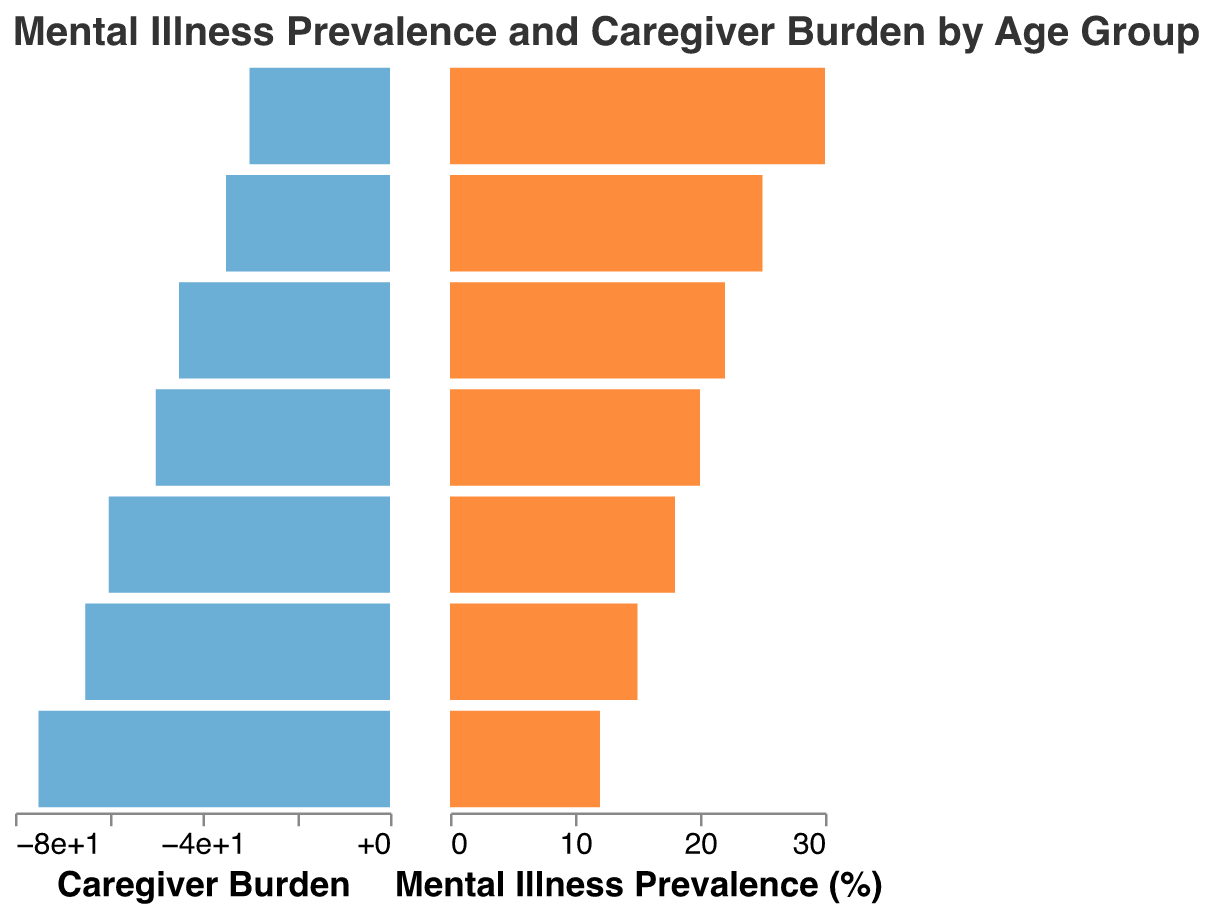What's the title of the figure? The title is placed at the top of the figure. It reads, "Mental Illness Prevalence and Caregiver Burden by Age Group".
Answer: Mental Illness Prevalence and Caregiver Burden by Age Group Which age group has the highest mental illness prevalence? By looking at the "Mental Illness Prevalence (%)" bar, the age group 75+ has the highest value at 30%.
Answer: 75+ Which age group experiences the highest caregiver burden? By observing the "Caregiver Burden" bar, the age group 45-54 has the highest burden at -75.
Answer: 45-54 What is the difference in mental illness prevalence between the age groups 45-54 and 75+? The mental illness prevalence for 45-54 is 20% and for 75+ is 30%. The difference is 30% - 20% = 10%.
Answer: 10% Is the caregiver burden higher for the age group 55-64 or 65-74? Observing the "Caregiver Burden" bars, the burden for 55-64 is -65, and for 65-74 is -50. -65 is less than -50 (more negative), indicating a higher burden.
Answer: 55-64 What is the caregiver burden for the age group 35-44? The "Caregiver Burden" bar for 35-44 shows a value of -60.
Answer: -60 Which age groups have a mental illness prevalence of more than 20%? The age groups with more than 20% mental illness prevalence, based on the "Mental Illness Prevalence (%)" bars, are 55-64 (22%), 65-74 (25%), and 75+ (30%).
Answer: 55-64, 65-74, 75+ Compare the mental illness prevalence of the youngest age group to the oldest. The youngest age group (15-24) has a mental illness prevalence of 12%, while the oldest (75+) has 30%. Hence, the oldest has a higher prevalence.
Answer: Oldest (75+) What is the total caregiver burden for all age groups combined? Summing all values: -30 + (-45) + (-60) + (-75) + (-65) + (-50) + (-35) = -360.
Answer: -360 